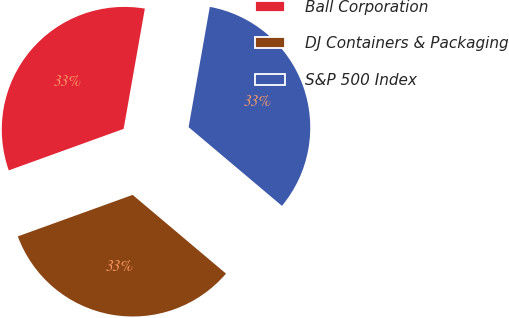Convert chart. <chart><loc_0><loc_0><loc_500><loc_500><pie_chart><fcel>Ball Corporation<fcel>DJ Containers & Packaging<fcel>S&P 500 Index<nl><fcel>33.3%<fcel>33.33%<fcel>33.37%<nl></chart> 